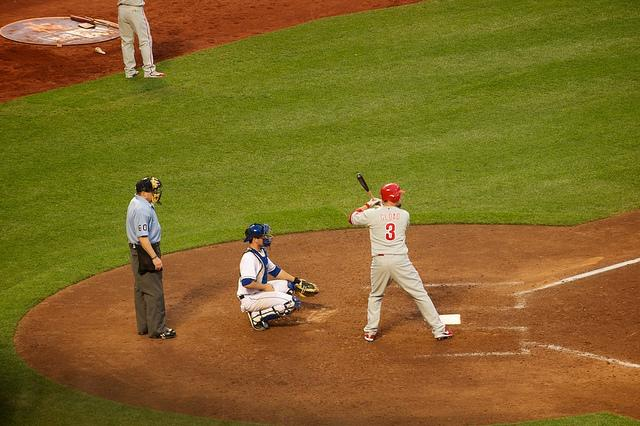Why is the batter wearing gloves? grip 